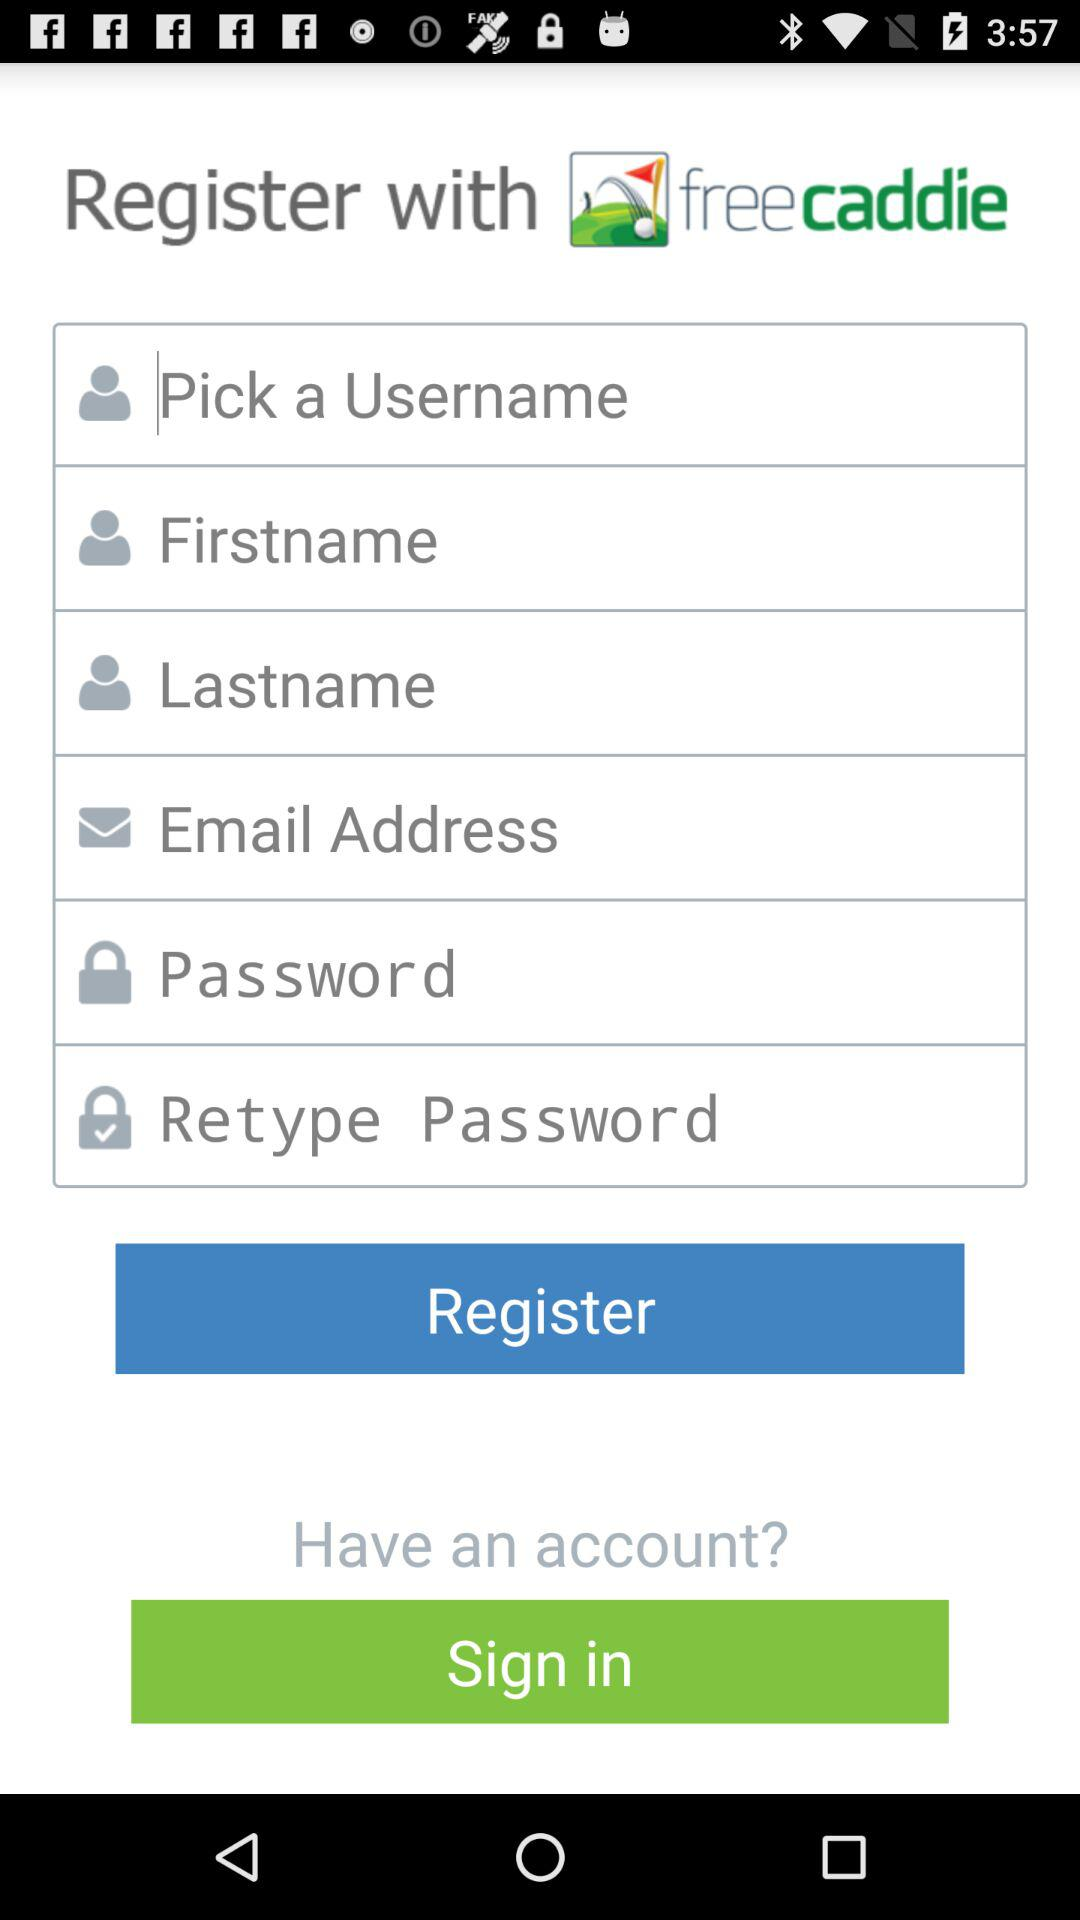How many text fields are there on this page?
Answer the question using a single word or phrase. 6 